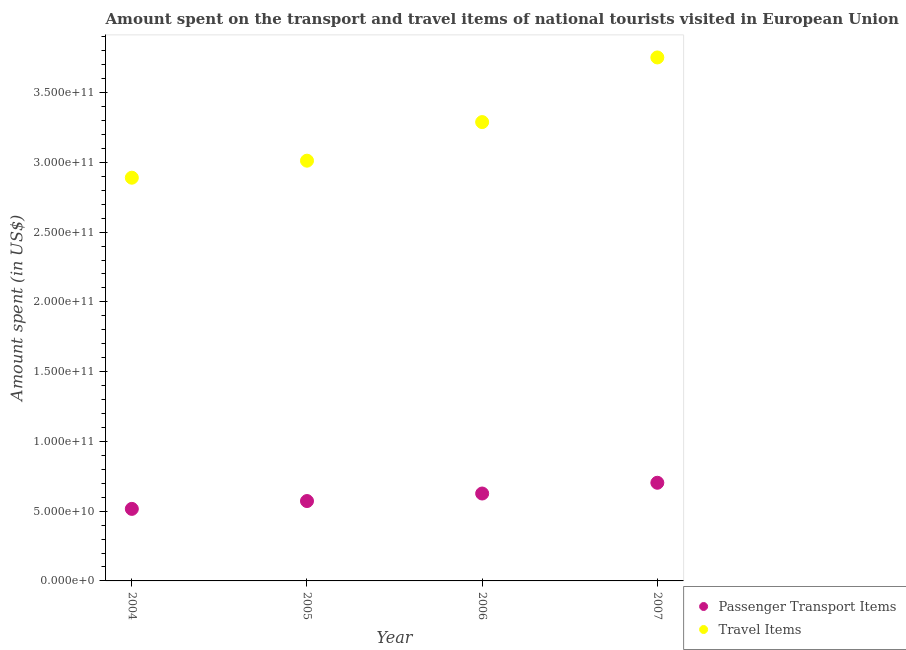Is the number of dotlines equal to the number of legend labels?
Keep it short and to the point. Yes. What is the amount spent in travel items in 2004?
Provide a succinct answer. 2.89e+11. Across all years, what is the maximum amount spent on passenger transport items?
Keep it short and to the point. 7.04e+1. Across all years, what is the minimum amount spent on passenger transport items?
Provide a succinct answer. 5.16e+1. In which year was the amount spent in travel items maximum?
Keep it short and to the point. 2007. What is the total amount spent in travel items in the graph?
Keep it short and to the point. 1.29e+12. What is the difference between the amount spent on passenger transport items in 2004 and that in 2005?
Offer a terse response. -5.62e+09. What is the difference between the amount spent in travel items in 2006 and the amount spent on passenger transport items in 2005?
Give a very brief answer. 2.72e+11. What is the average amount spent in travel items per year?
Ensure brevity in your answer.  3.24e+11. In the year 2007, what is the difference between the amount spent on passenger transport items and amount spent in travel items?
Make the answer very short. -3.05e+11. In how many years, is the amount spent in travel items greater than 280000000000 US$?
Give a very brief answer. 4. What is the ratio of the amount spent in travel items in 2004 to that in 2006?
Offer a terse response. 0.88. Is the amount spent on passenger transport items in 2006 less than that in 2007?
Offer a very short reply. Yes. What is the difference between the highest and the second highest amount spent in travel items?
Provide a succinct answer. 4.63e+1. What is the difference between the highest and the lowest amount spent on passenger transport items?
Provide a succinct answer. 1.87e+1. Does the amount spent on passenger transport items monotonically increase over the years?
Your answer should be compact. Yes. Is the amount spent in travel items strictly less than the amount spent on passenger transport items over the years?
Offer a terse response. No. How many dotlines are there?
Offer a very short reply. 2. Are the values on the major ticks of Y-axis written in scientific E-notation?
Your response must be concise. Yes. Does the graph contain grids?
Give a very brief answer. No. Where does the legend appear in the graph?
Provide a short and direct response. Bottom right. How many legend labels are there?
Make the answer very short. 2. What is the title of the graph?
Provide a short and direct response. Amount spent on the transport and travel items of national tourists visited in European Union. Does "Nitrous oxide emissions" appear as one of the legend labels in the graph?
Keep it short and to the point. No. What is the label or title of the Y-axis?
Your answer should be compact. Amount spent (in US$). What is the Amount spent (in US$) in Passenger Transport Items in 2004?
Ensure brevity in your answer.  5.16e+1. What is the Amount spent (in US$) in Travel Items in 2004?
Ensure brevity in your answer.  2.89e+11. What is the Amount spent (in US$) in Passenger Transport Items in 2005?
Your answer should be very brief. 5.72e+1. What is the Amount spent (in US$) in Travel Items in 2005?
Ensure brevity in your answer.  3.01e+11. What is the Amount spent (in US$) of Passenger Transport Items in 2006?
Provide a succinct answer. 6.26e+1. What is the Amount spent (in US$) of Travel Items in 2006?
Offer a terse response. 3.29e+11. What is the Amount spent (in US$) in Passenger Transport Items in 2007?
Offer a terse response. 7.04e+1. What is the Amount spent (in US$) of Travel Items in 2007?
Make the answer very short. 3.75e+11. Across all years, what is the maximum Amount spent (in US$) in Passenger Transport Items?
Make the answer very short. 7.04e+1. Across all years, what is the maximum Amount spent (in US$) in Travel Items?
Your answer should be very brief. 3.75e+11. Across all years, what is the minimum Amount spent (in US$) of Passenger Transport Items?
Offer a terse response. 5.16e+1. Across all years, what is the minimum Amount spent (in US$) in Travel Items?
Offer a terse response. 2.89e+11. What is the total Amount spent (in US$) in Passenger Transport Items in the graph?
Your answer should be compact. 2.42e+11. What is the total Amount spent (in US$) of Travel Items in the graph?
Keep it short and to the point. 1.29e+12. What is the difference between the Amount spent (in US$) in Passenger Transport Items in 2004 and that in 2005?
Your answer should be compact. -5.62e+09. What is the difference between the Amount spent (in US$) in Travel Items in 2004 and that in 2005?
Offer a very short reply. -1.22e+1. What is the difference between the Amount spent (in US$) of Passenger Transport Items in 2004 and that in 2006?
Offer a very short reply. -1.10e+1. What is the difference between the Amount spent (in US$) of Travel Items in 2004 and that in 2006?
Make the answer very short. -3.99e+1. What is the difference between the Amount spent (in US$) of Passenger Transport Items in 2004 and that in 2007?
Give a very brief answer. -1.87e+1. What is the difference between the Amount spent (in US$) of Travel Items in 2004 and that in 2007?
Provide a short and direct response. -8.62e+1. What is the difference between the Amount spent (in US$) in Passenger Transport Items in 2005 and that in 2006?
Provide a short and direct response. -5.40e+09. What is the difference between the Amount spent (in US$) in Travel Items in 2005 and that in 2006?
Your answer should be very brief. -2.77e+1. What is the difference between the Amount spent (in US$) of Passenger Transport Items in 2005 and that in 2007?
Provide a succinct answer. -1.31e+1. What is the difference between the Amount spent (in US$) in Travel Items in 2005 and that in 2007?
Keep it short and to the point. -7.40e+1. What is the difference between the Amount spent (in US$) in Passenger Transport Items in 2006 and that in 2007?
Your answer should be compact. -7.71e+09. What is the difference between the Amount spent (in US$) in Travel Items in 2006 and that in 2007?
Make the answer very short. -4.63e+1. What is the difference between the Amount spent (in US$) of Passenger Transport Items in 2004 and the Amount spent (in US$) of Travel Items in 2005?
Make the answer very short. -2.50e+11. What is the difference between the Amount spent (in US$) of Passenger Transport Items in 2004 and the Amount spent (in US$) of Travel Items in 2006?
Your answer should be very brief. -2.77e+11. What is the difference between the Amount spent (in US$) in Passenger Transport Items in 2004 and the Amount spent (in US$) in Travel Items in 2007?
Ensure brevity in your answer.  -3.24e+11. What is the difference between the Amount spent (in US$) of Passenger Transport Items in 2005 and the Amount spent (in US$) of Travel Items in 2006?
Provide a succinct answer. -2.72e+11. What is the difference between the Amount spent (in US$) of Passenger Transport Items in 2005 and the Amount spent (in US$) of Travel Items in 2007?
Offer a terse response. -3.18e+11. What is the difference between the Amount spent (in US$) of Passenger Transport Items in 2006 and the Amount spent (in US$) of Travel Items in 2007?
Offer a very short reply. -3.13e+11. What is the average Amount spent (in US$) of Passenger Transport Items per year?
Offer a very short reply. 6.05e+1. What is the average Amount spent (in US$) in Travel Items per year?
Your answer should be compact. 3.24e+11. In the year 2004, what is the difference between the Amount spent (in US$) in Passenger Transport Items and Amount spent (in US$) in Travel Items?
Provide a short and direct response. -2.37e+11. In the year 2005, what is the difference between the Amount spent (in US$) in Passenger Transport Items and Amount spent (in US$) in Travel Items?
Offer a terse response. -2.44e+11. In the year 2006, what is the difference between the Amount spent (in US$) in Passenger Transport Items and Amount spent (in US$) in Travel Items?
Ensure brevity in your answer.  -2.66e+11. In the year 2007, what is the difference between the Amount spent (in US$) of Passenger Transport Items and Amount spent (in US$) of Travel Items?
Provide a short and direct response. -3.05e+11. What is the ratio of the Amount spent (in US$) of Passenger Transport Items in 2004 to that in 2005?
Give a very brief answer. 0.9. What is the ratio of the Amount spent (in US$) in Travel Items in 2004 to that in 2005?
Provide a succinct answer. 0.96. What is the ratio of the Amount spent (in US$) in Passenger Transport Items in 2004 to that in 2006?
Provide a short and direct response. 0.82. What is the ratio of the Amount spent (in US$) in Travel Items in 2004 to that in 2006?
Offer a very short reply. 0.88. What is the ratio of the Amount spent (in US$) in Passenger Transport Items in 2004 to that in 2007?
Offer a very short reply. 0.73. What is the ratio of the Amount spent (in US$) of Travel Items in 2004 to that in 2007?
Provide a short and direct response. 0.77. What is the ratio of the Amount spent (in US$) in Passenger Transport Items in 2005 to that in 2006?
Offer a terse response. 0.91. What is the ratio of the Amount spent (in US$) in Travel Items in 2005 to that in 2006?
Provide a succinct answer. 0.92. What is the ratio of the Amount spent (in US$) in Passenger Transport Items in 2005 to that in 2007?
Keep it short and to the point. 0.81. What is the ratio of the Amount spent (in US$) in Travel Items in 2005 to that in 2007?
Your answer should be very brief. 0.8. What is the ratio of the Amount spent (in US$) of Passenger Transport Items in 2006 to that in 2007?
Your answer should be very brief. 0.89. What is the ratio of the Amount spent (in US$) in Travel Items in 2006 to that in 2007?
Provide a short and direct response. 0.88. What is the difference between the highest and the second highest Amount spent (in US$) of Passenger Transport Items?
Provide a succinct answer. 7.71e+09. What is the difference between the highest and the second highest Amount spent (in US$) in Travel Items?
Keep it short and to the point. 4.63e+1. What is the difference between the highest and the lowest Amount spent (in US$) in Passenger Transport Items?
Offer a very short reply. 1.87e+1. What is the difference between the highest and the lowest Amount spent (in US$) of Travel Items?
Provide a succinct answer. 8.62e+1. 